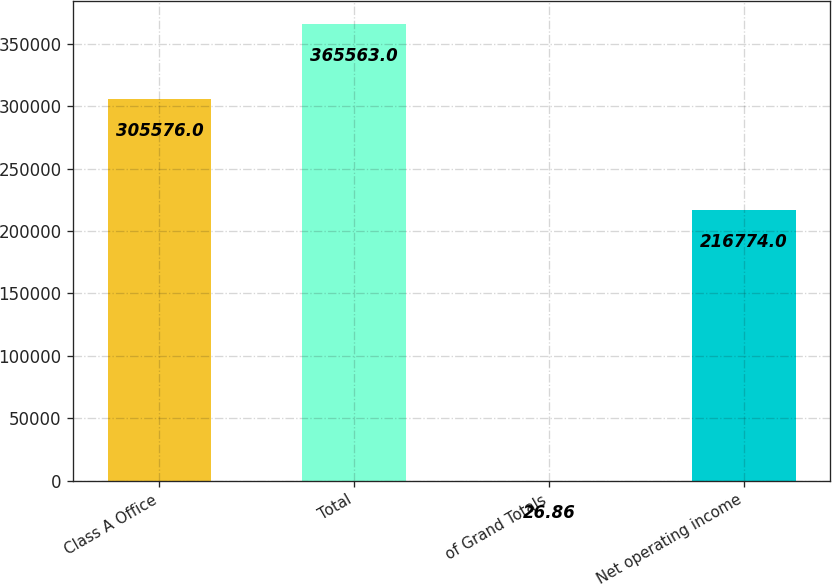Convert chart. <chart><loc_0><loc_0><loc_500><loc_500><bar_chart><fcel>Class A Office<fcel>Total<fcel>of Grand Totals<fcel>Net operating income<nl><fcel>305576<fcel>365563<fcel>26.86<fcel>216774<nl></chart> 